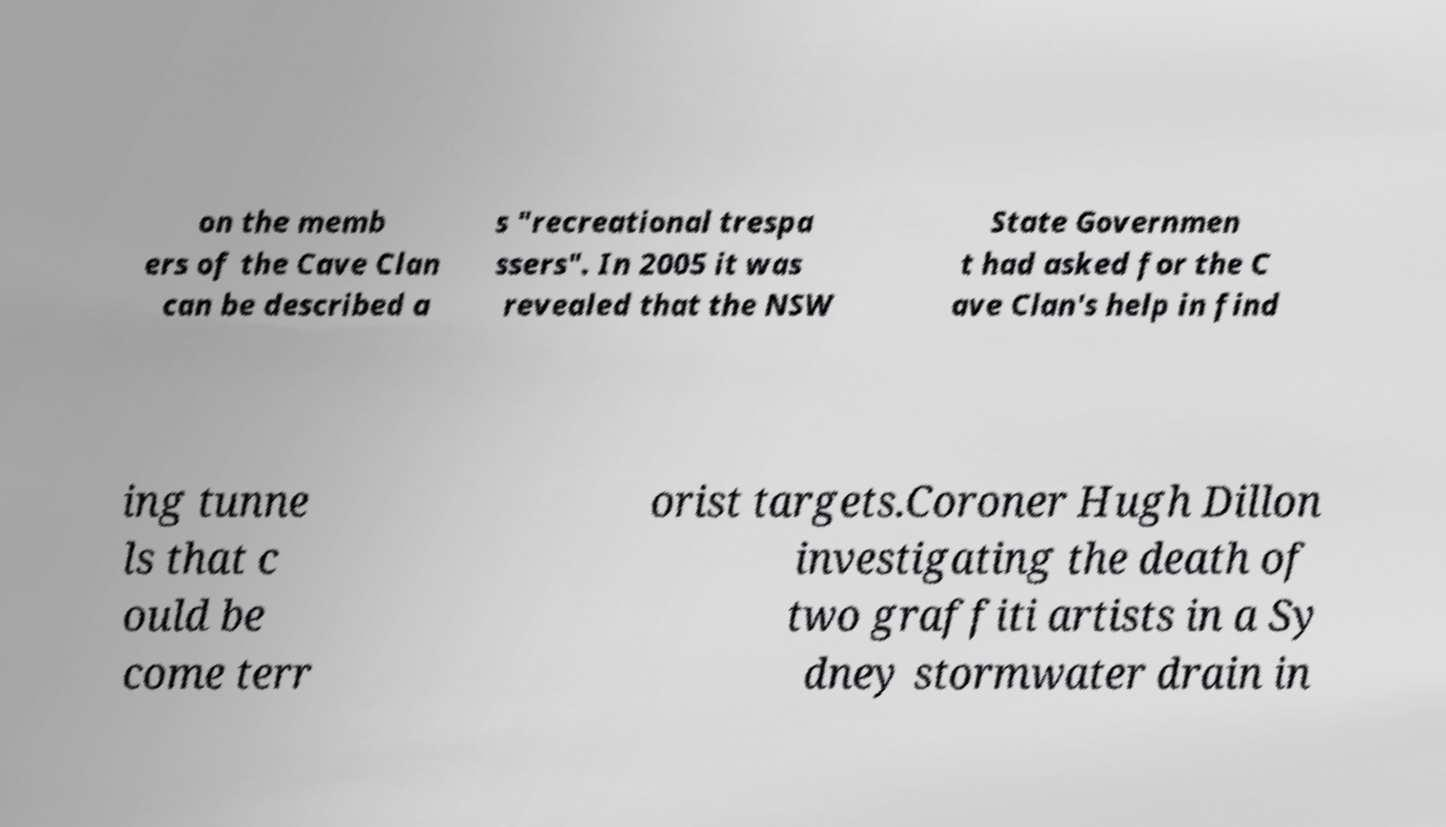Could you assist in decoding the text presented in this image and type it out clearly? on the memb ers of the Cave Clan can be described a s "recreational trespa ssers". In 2005 it was revealed that the NSW State Governmen t had asked for the C ave Clan's help in find ing tunne ls that c ould be come terr orist targets.Coroner Hugh Dillon investigating the death of two graffiti artists in a Sy dney stormwater drain in 